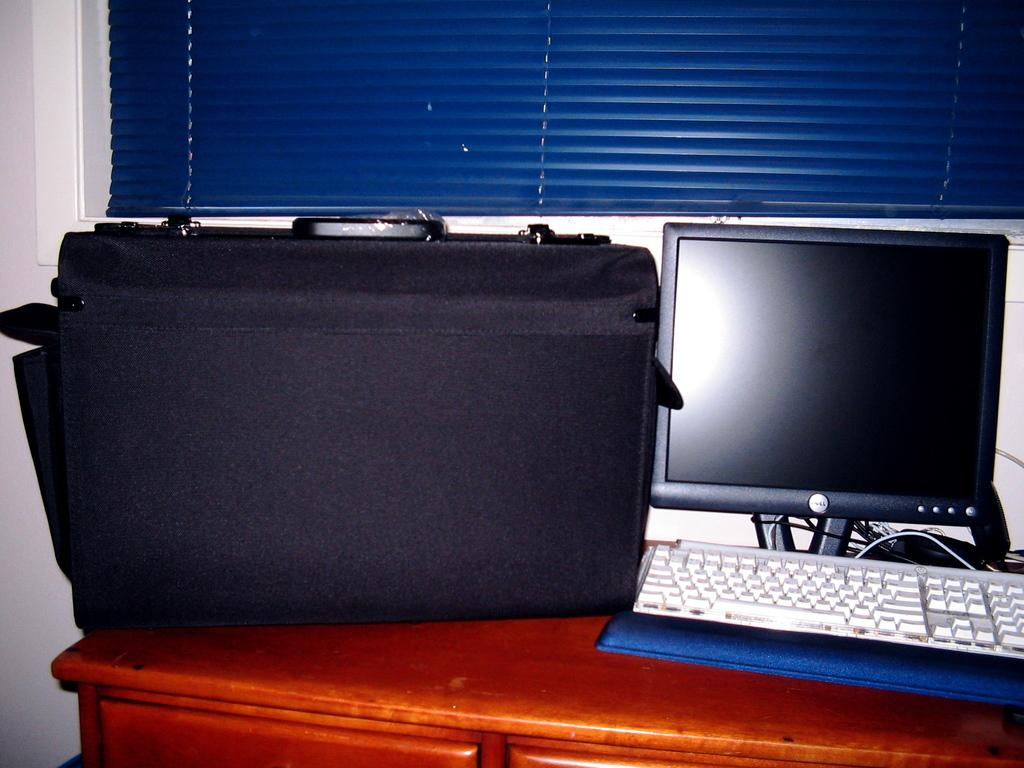What object can be seen in the image that people might use to carry items? There is a bag in the image that people might use to carry items. What electronic device is visible in the image? There is a monitor in the image. What is used for typing or inputting commands in the image? There is a keyboard in the image. Where are these objects located in the image? All these objects are on a table. What can be seen in the background of the image? There is a wall and a window blind in the background of the image. Can you see any goldfish swimming in the image? No, there are no goldfish present in the image. Is there any indication of pain or discomfort in the image? No, there is no indication of pain or discomfort in the image. 